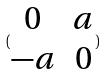<formula> <loc_0><loc_0><loc_500><loc_500>( \begin{matrix} 0 & a \\ - a & 0 \end{matrix} )</formula> 